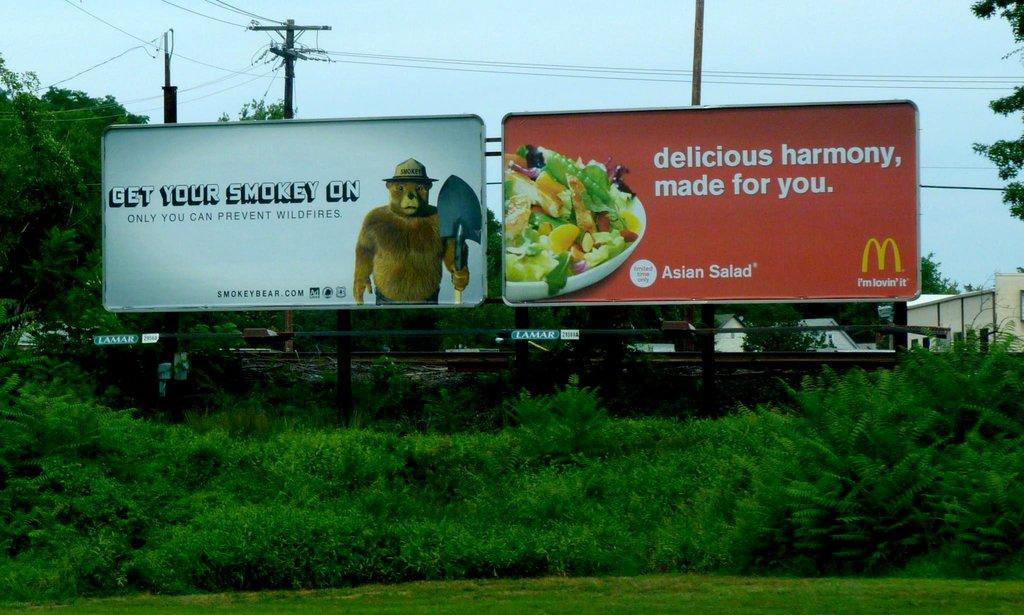<image>
Summarize the visual content of the image. A pair of billboard signs one of them for McDonalds. 